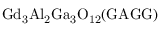Convert formula to latex. <formula><loc_0><loc_0><loc_500><loc_500>G d _ { 3 } A l _ { 2 } G a _ { 3 } O _ { 1 2 } ( G A G G )</formula> 